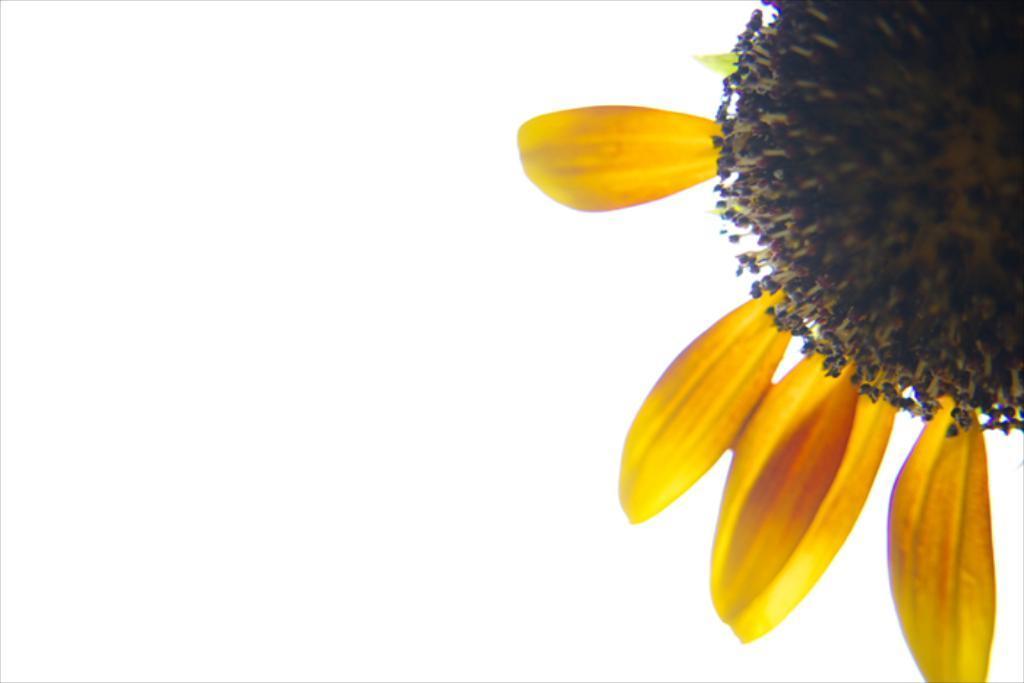In one or two sentences, can you explain what this image depicts? In this image we can see a sunflower with few petals. 